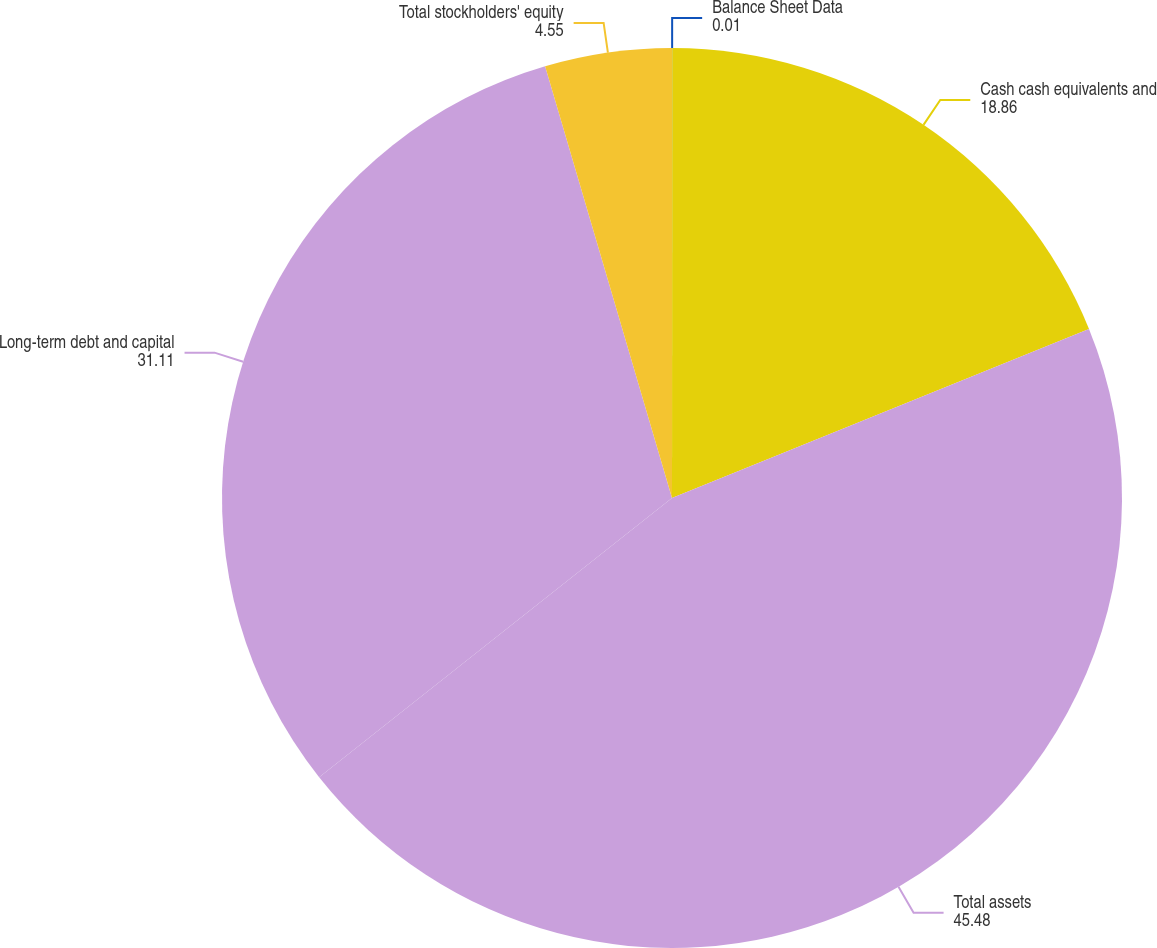Convert chart to OTSL. <chart><loc_0><loc_0><loc_500><loc_500><pie_chart><fcel>Balance Sheet Data<fcel>Cash cash equivalents and<fcel>Total assets<fcel>Long-term debt and capital<fcel>Total stockholders' equity<nl><fcel>0.01%<fcel>18.86%<fcel>45.48%<fcel>31.11%<fcel>4.55%<nl></chart> 